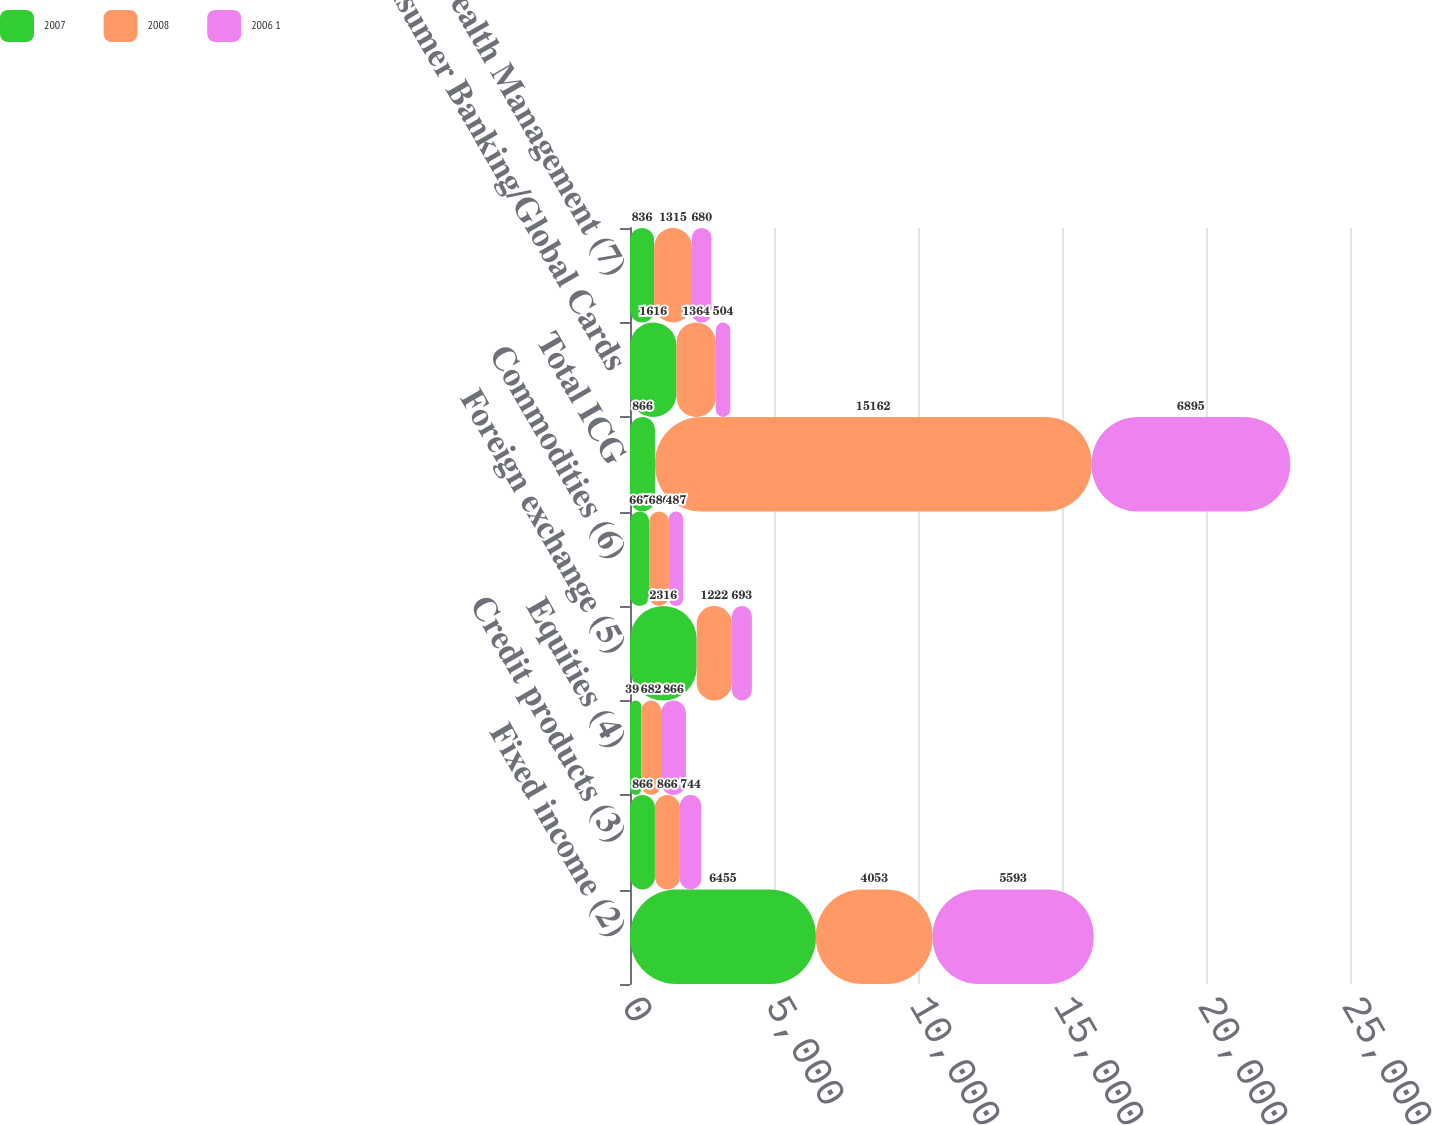Convert chart to OTSL. <chart><loc_0><loc_0><loc_500><loc_500><stacked_bar_chart><ecel><fcel>Fixed income (2)<fcel>Credit products (3)<fcel>Equities (4)<fcel>Foreign exchange (5)<fcel>Commodities (6)<fcel>Total ICG<fcel>Consumer Banking/Global Cards<fcel>Global Wealth Management (7)<nl><fcel>2007<fcel>6455<fcel>866<fcel>394<fcel>2316<fcel>667<fcel>866<fcel>1616<fcel>836<nl><fcel>2008<fcel>4053<fcel>866<fcel>682<fcel>1222<fcel>686<fcel>15162<fcel>1364<fcel>1315<nl><fcel>2006 1<fcel>5593<fcel>744<fcel>866<fcel>693<fcel>487<fcel>6895<fcel>504<fcel>680<nl></chart> 